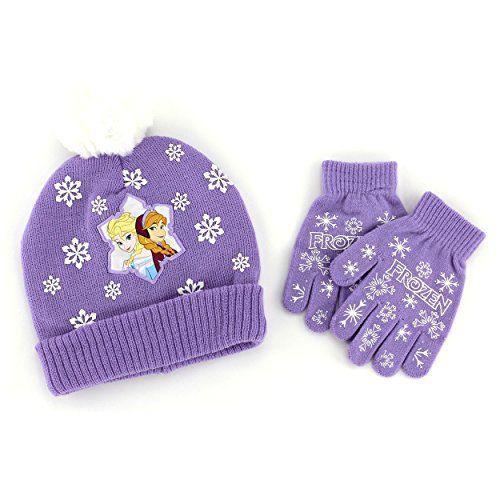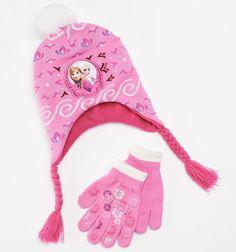The first image is the image on the left, the second image is the image on the right. For the images shown, is this caption "One image shows a pair of mittens, not gloves, next to a blue cap with a pom-pom ball on top." true? Answer yes or no. No. The first image is the image on the left, the second image is the image on the right. Assess this claim about the two images: "One of the images contains a blue beanie with two blue gloves.". Correct or not? Answer yes or no. No. 